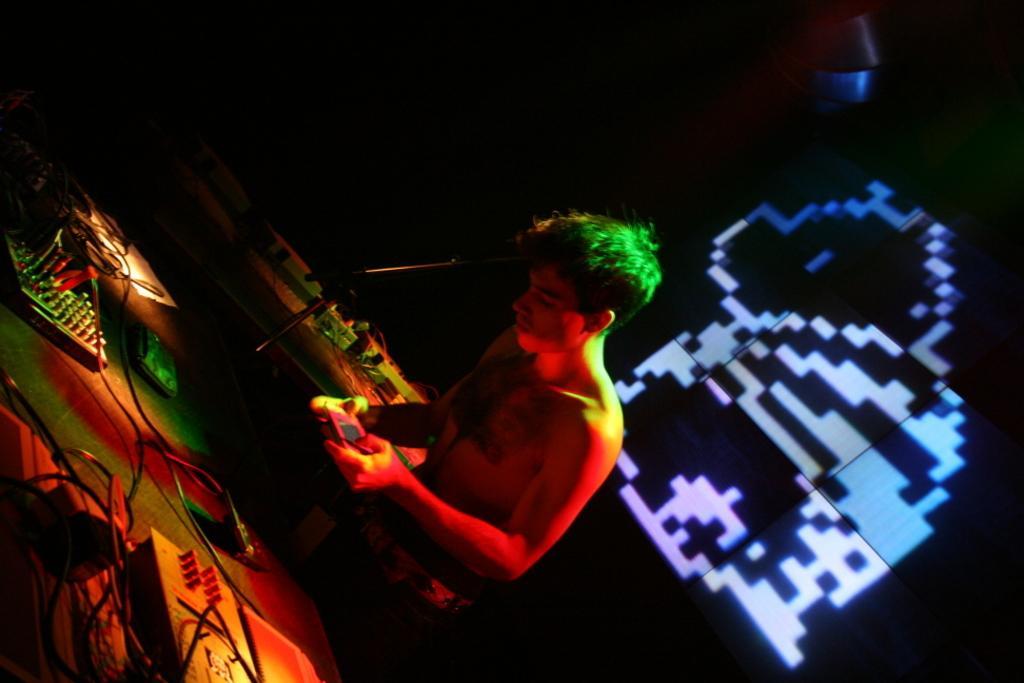How would you summarize this image in a sentence or two? In this image I can see a person standing and holding an object. There are DJ systems, cables and in the background it looks like a screen. 